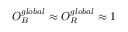Convert formula to latex. <formula><loc_0><loc_0><loc_500><loc_500>O _ { B } ^ { g l o b a l } \approx O _ { R } ^ { g l o b a l } \approx 1</formula> 